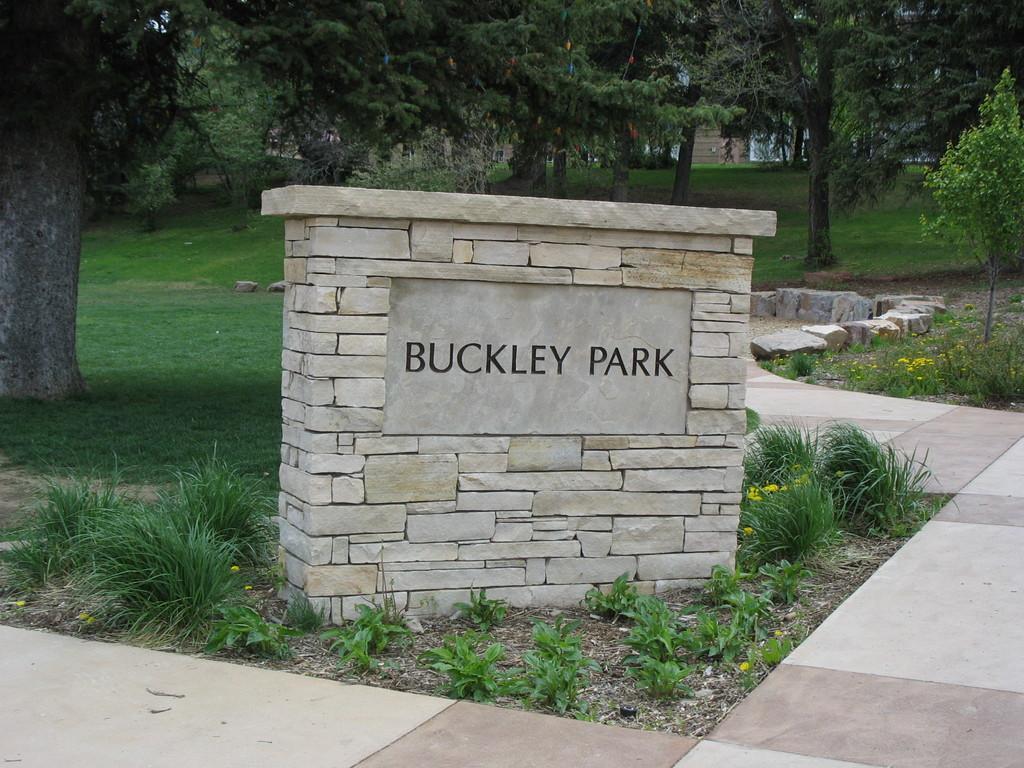In one or two sentences, can you explain what this image depicts? In this picture I can see there is a nameplate and there is a walk way. There is grass and rocks and there are trees, there are few people walking here and there is a building in the backdrop. 